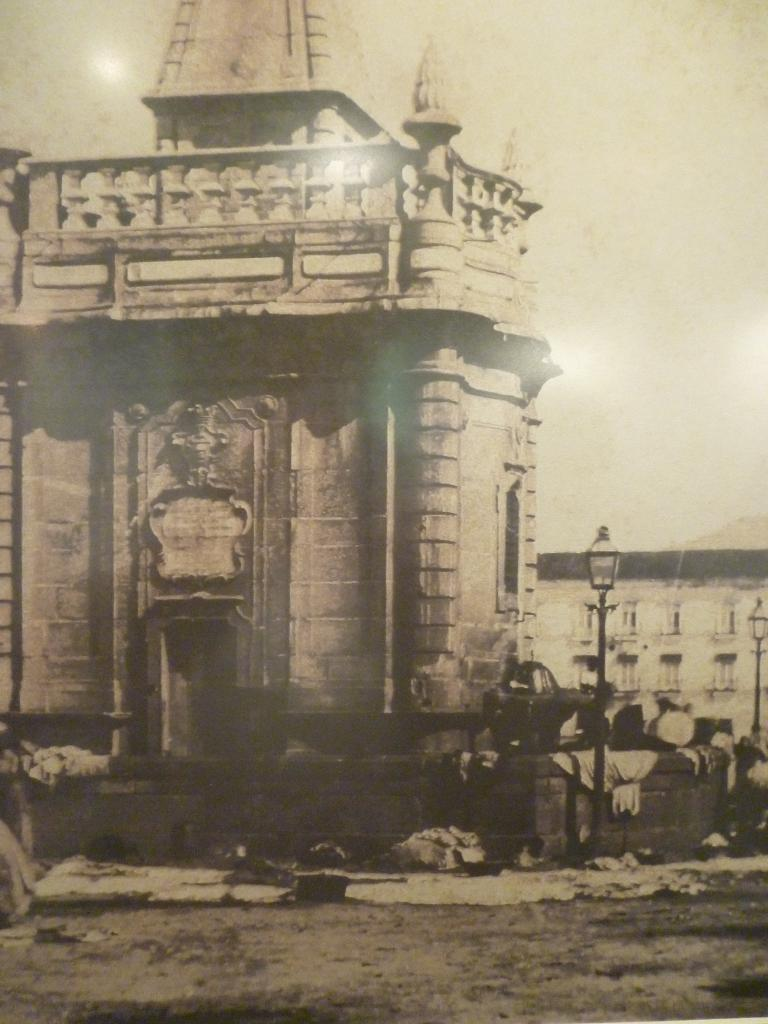What type of structures are visible in the image? There are buildings in the image. Where are the poles and lights located in the image? The two poles and lights are on the right side of the image. What type of unit is being transported by the laborer in the image? There is no laborer or unit present in the image. What type of cart is being used to carry the unit in the image? There is no cart or unit present in the image. 